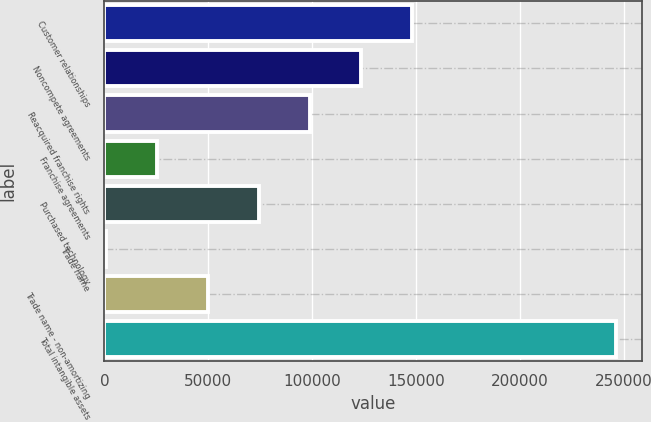Convert chart. <chart><loc_0><loc_0><loc_500><loc_500><bar_chart><fcel>Customer relationships<fcel>Noncompete agreements<fcel>Reacquired franchise rights<fcel>Franchise agreements<fcel>Purchased technology<fcel>Trade name<fcel>Trade name - non-amortizing<fcel>Total intangible assets<nl><fcel>148128<fcel>123540<fcel>98952<fcel>25188<fcel>74364<fcel>600<fcel>49776<fcel>246480<nl></chart> 